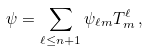<formula> <loc_0><loc_0><loc_500><loc_500>\psi = \sum _ { \ell \leq n + 1 } \psi _ { \ell m } T ^ { \ell } _ { m } \, ,</formula> 